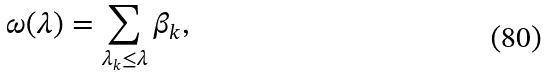Convert formula to latex. <formula><loc_0><loc_0><loc_500><loc_500>\omega ( \lambda ) = \sum _ { \lambda _ { k } \leq \lambda } \beta _ { k } ,</formula> 